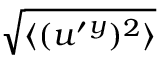Convert formula to latex. <formula><loc_0><loc_0><loc_500><loc_500>\sqrt { \langle { ( u ^ { \prime ^ { y } ) ^ { 2 } } \rangle }</formula> 